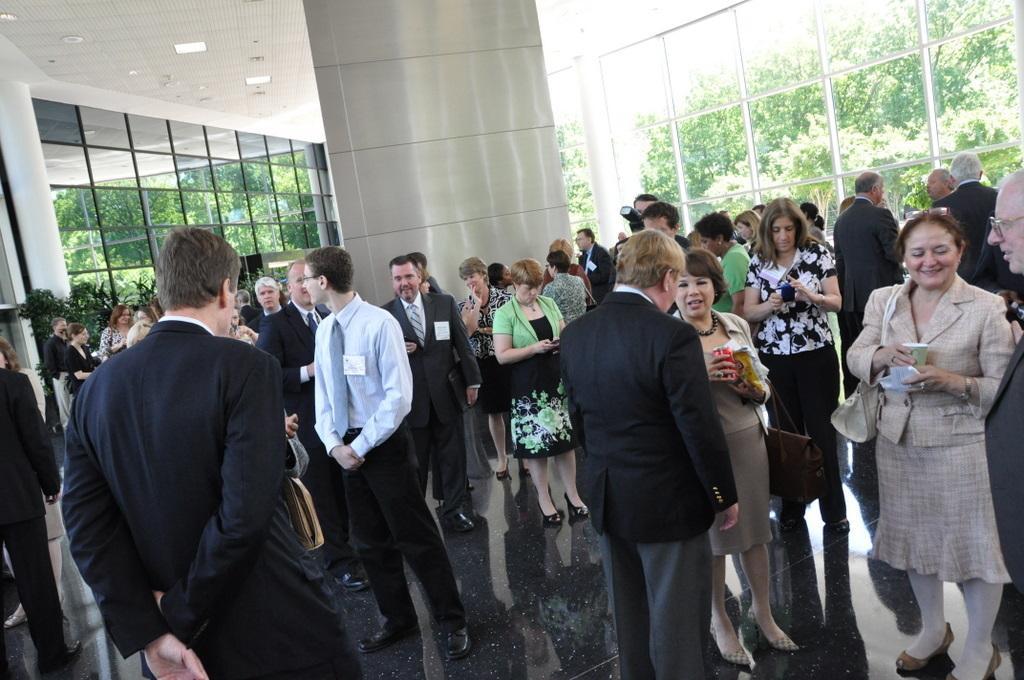Can you describe this image briefly? In the foreground of this image, there are persons standing holding mobile phones, cups, tins in their hands. In the background, there is a pillar, ceiling, glass wall and through the glass, we can see the greenery. 